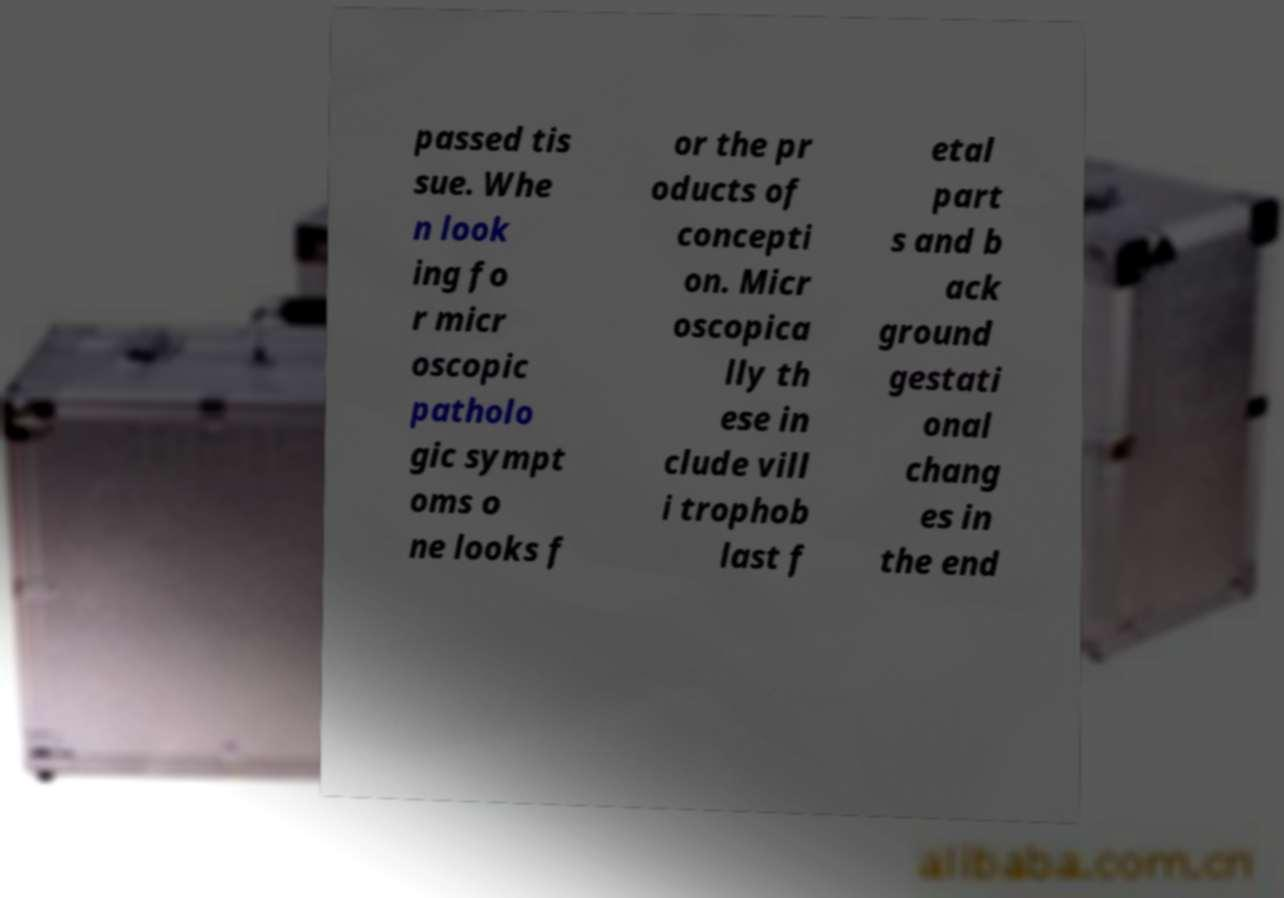Can you read and provide the text displayed in the image?This photo seems to have some interesting text. Can you extract and type it out for me? passed tis sue. Whe n look ing fo r micr oscopic patholo gic sympt oms o ne looks f or the pr oducts of concepti on. Micr oscopica lly th ese in clude vill i trophob last f etal part s and b ack ground gestati onal chang es in the end 